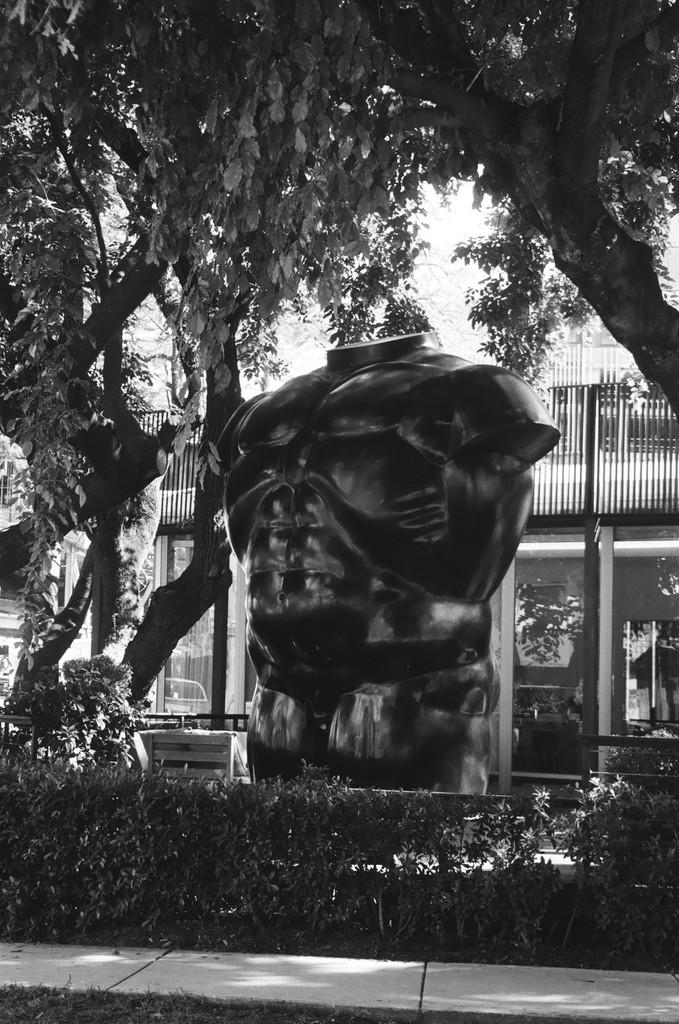What is the color scheme of the image? The image is black and white. What is the main subject of the image? There is a statue at the center of the image. What type of natural elements can be seen in the image? There are trees and plants in the image. What type of man-made structure is visible in the background? There is a building in the background of the image. How many skirts can be seen on the statue in the image? There are no skirts present in the image, as the statue is not wearing any clothing. What type of system is being used to power the statue in the image? The image does not provide any information about the statue being powered by a system, nor is there any indication that the statue is moving or requires power. 